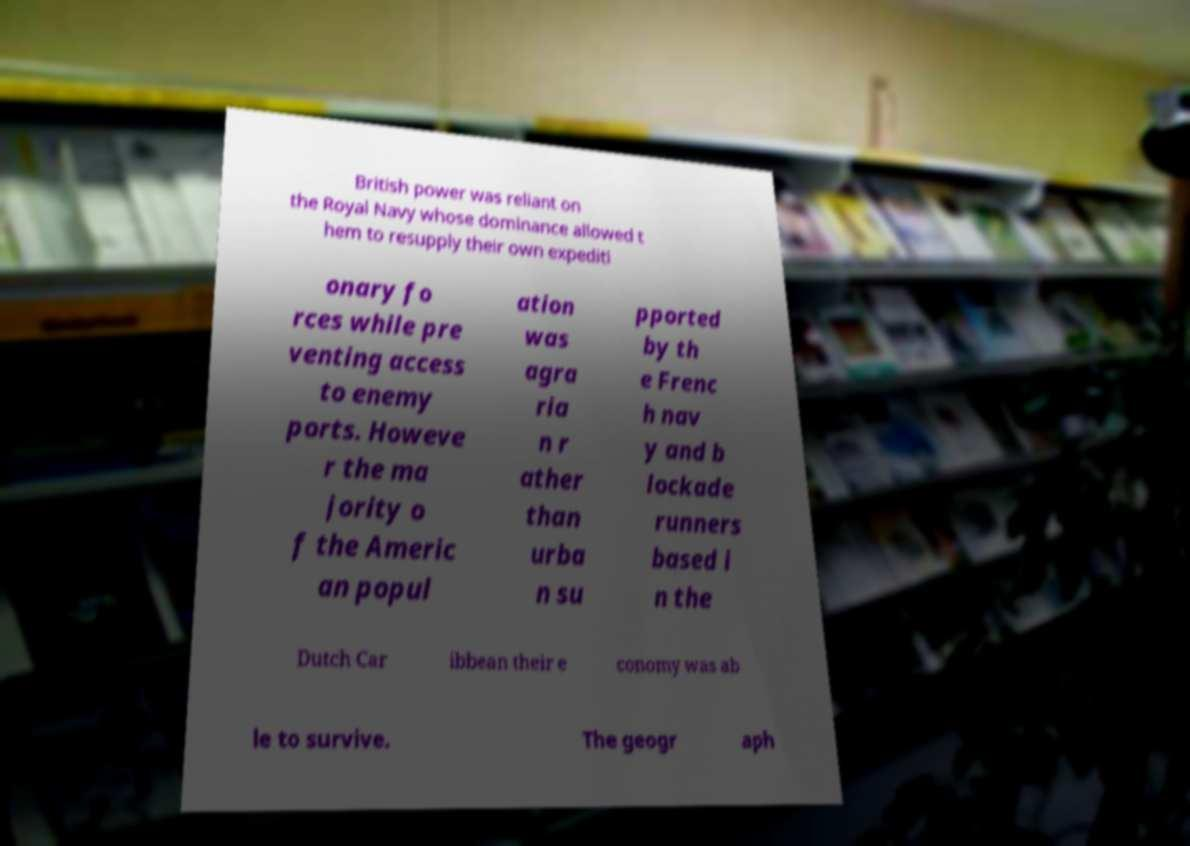Please identify and transcribe the text found in this image. British power was reliant on the Royal Navy whose dominance allowed t hem to resupply their own expediti onary fo rces while pre venting access to enemy ports. Howeve r the ma jority o f the Americ an popul ation was agra ria n r ather than urba n su pported by th e Frenc h nav y and b lockade runners based i n the Dutch Car ibbean their e conomy was ab le to survive. The geogr aph 